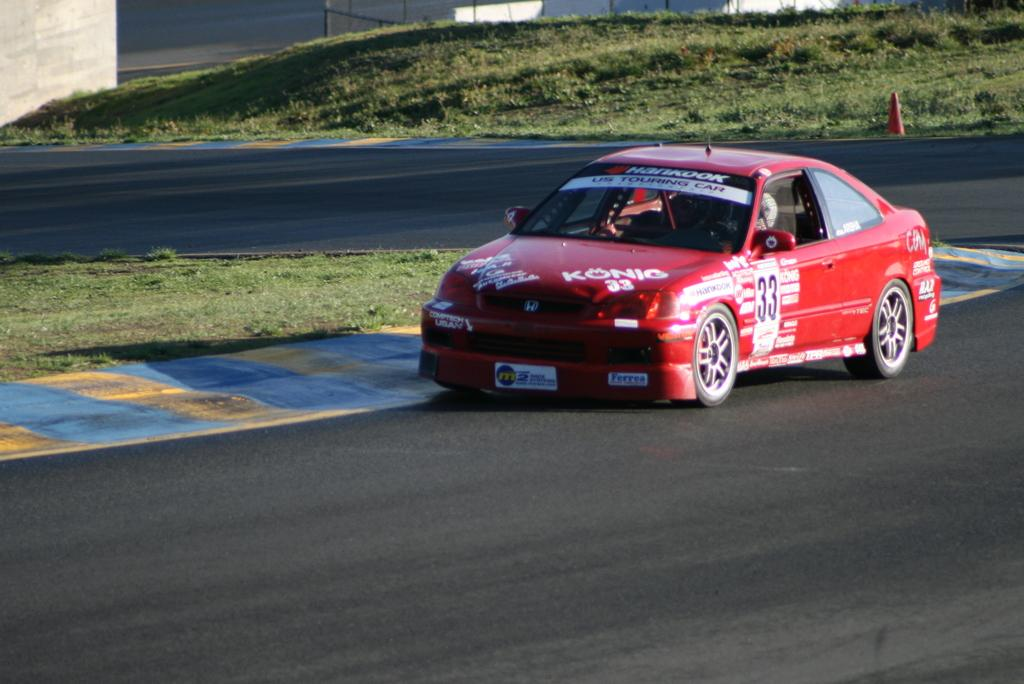What is the main subject of the image? The main subject of the image is a car on the road. What type of vegetation can be seen in the image? There is grass visible in the image. What object is present to guide or warn drivers in the image? There is a traffic cone in the image. What structures can be seen in the background of the image? There is a wall and a fence in the background of the image. What type of hole can be seen in the image? There is no hole present in the image. Where is the lunchroom located in the image? There is no lunchroom present in the image. 